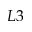Convert formula to latex. <formula><loc_0><loc_0><loc_500><loc_500>L 3</formula> 